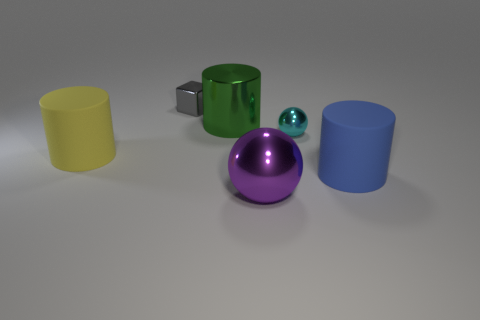Add 3 shiny things. How many objects exist? 9 Subtract all balls. How many objects are left? 4 Subtract 0 brown spheres. How many objects are left? 6 Subtract all large yellow cylinders. Subtract all tiny metallic objects. How many objects are left? 3 Add 4 metal balls. How many metal balls are left? 6 Add 5 cyan balls. How many cyan balls exist? 6 